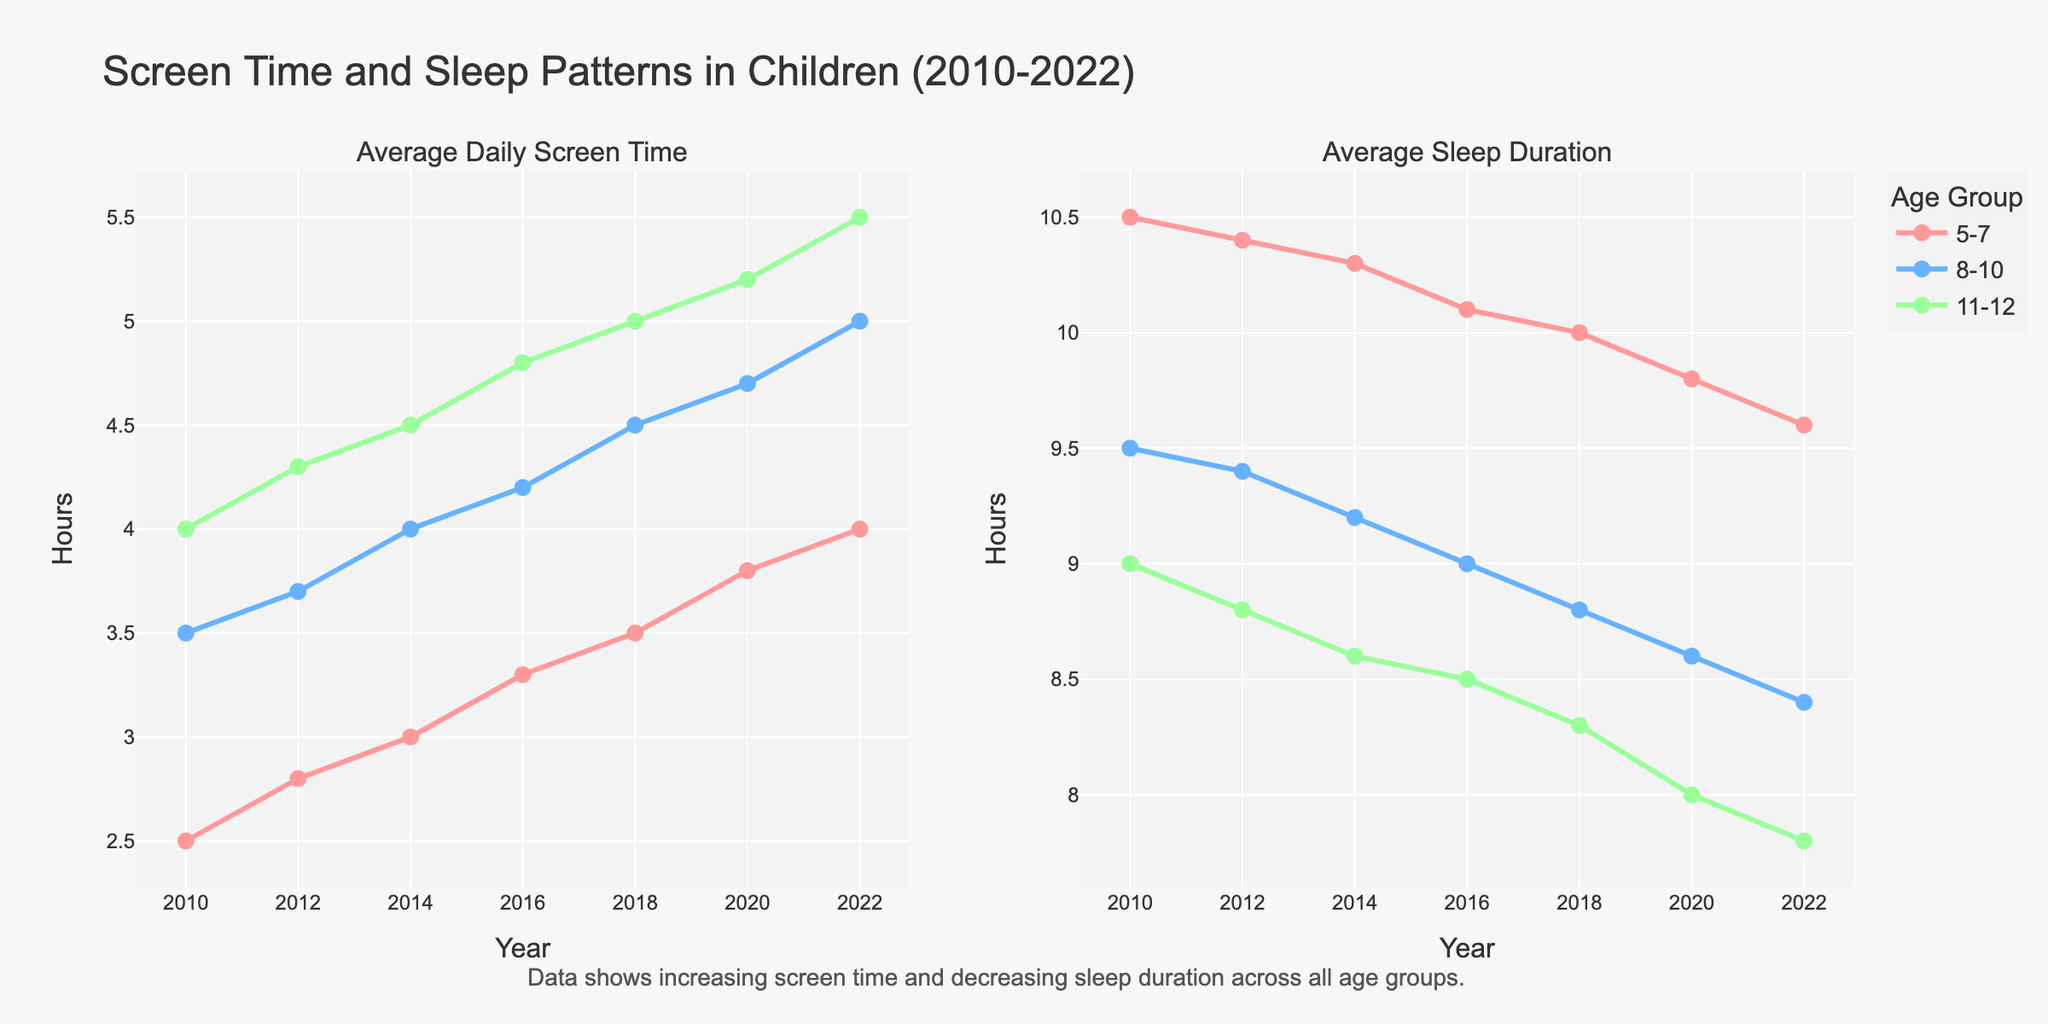What is the title of the figure? The title is located at the top of the figure in large font, presenting the context of the data being visualized: "Screen Time and Sleep Patterns in Children (2010-2022)."
Answer: Screen Time and Sleep Patterns in Children (2010-2022) What are the y-axis labels for the two subplots? Both subplots have y-axis labels indicating what is being measured. The left subplot y-axis is labeled "Average Daily Screen Time (hours)" and the right subplot y-axis is labeled "Average Sleep Duration (hours)."
Answer: Average Daily Screen Time (hours), Average Sleep Duration (hours) Which age group has shown the greatest increase in average daily screen time from 2010 to 2022? By examining the left subplot, trace the lines representing each age group from 2010 to 2022. The '11-12' age group has the most significant upward trend.
Answer: 11-12 How much did the average sleep duration change for the 8-10 age group between 2010 and 2022? Locate the '8-10' age group line in the right subplot and compare the values in 2010 and 2022. In 2010 it was 9.5 hours, and in 2022 it is 8.4 hours. The change is 9.5 - 8.4 = 1.1 hours.
Answer: 1.1 hours Which year shows the highest average screen time for children aged 5-7? Check the left subplot for the '5-7' age group line. The highest point appears in 2022, where they spent about 4.0 hours on average.
Answer: 2022 What is the general trend of sleep duration for children aged 5-7 from 2010 to 2022? Examine the right subplot and follow the '5-7' age group line from 2010 to 2022. There is a decreasing trend where the average sleep duration drops from 10.5 hours to 9.6 hours.
Answer: Decreasing In which years do the average screen time for the '8-10' age group exceed 4 hours? Look for points on the '8-10' age group line in the left subplot where the value exceeds 4. This occurs in 2014, 2016, 2018, 2020, and 2022.
Answer: 2014, 2016, 2018, 2020, 2022 How much did the average screen time increase for the '11-12' age group from 2014 to 2022? In the left subplot, locate the values for the '11-12' age group in 2014 and 2022. In 2014, it was 4.5 hours, and in 2022, it is 5.5 hours. The increase is 5.5 - 4.5 = 1 hour.
Answer: 1 hour 